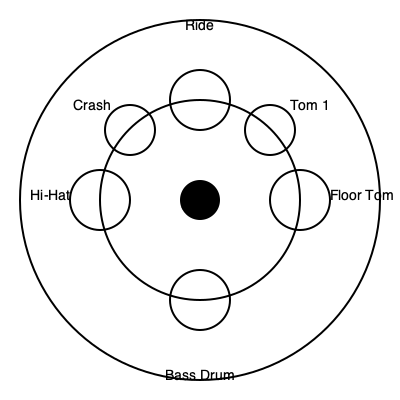Given the top-down view of a standard drum kit arrangement, what is the optimal angle between the hi-hat and the ride cymbal to ensure efficient movement and reduce strain during performance? To determine the optimal angle between the hi-hat and ride cymbal, we need to consider the ergonomics and efficiency of movement for the drummer. Let's approach this step-by-step:

1. Identify the positions: The hi-hat is on the left side of the kit, and the ride cymbal is at the top.

2. Consider the center: The snare drum is at the center, which is the primary reference point for the drummer's position.

3. Analyze the movement: The drummer needs to move between the hi-hat and ride cymbal frequently while maintaining a central position over the snare.

4. Optimal angle calculation:
   - An angle too small would crowd the space and limit movement.
   - An angle too large would require excessive reaching and strain.
   - The ideal angle allows for a natural arm position and easy transitions.

5. Standard practice: In most professional setups, the angle between the hi-hat and ride cymbal is approximately 90 degrees (or slightly less).

6. Reasoning: A 90-degree angle:
   - Provides a clear separation between left and right side components
   - Allows for a natural arm position when playing either cymbal
   - Facilitates quick transitions between the two without overreaching

7. Fine-tuning: Some drummers may prefer a slightly smaller angle (80-85 degrees) for a more compact setup, but this is a matter of personal preference and playing style.

The optimal angle of about 90 degrees creates an efficient triangle between the snare (center), hi-hat (left), and ride cymbal (top), allowing for smooth transitions and reduced physical strain during performances.
Answer: Approximately 90 degrees 